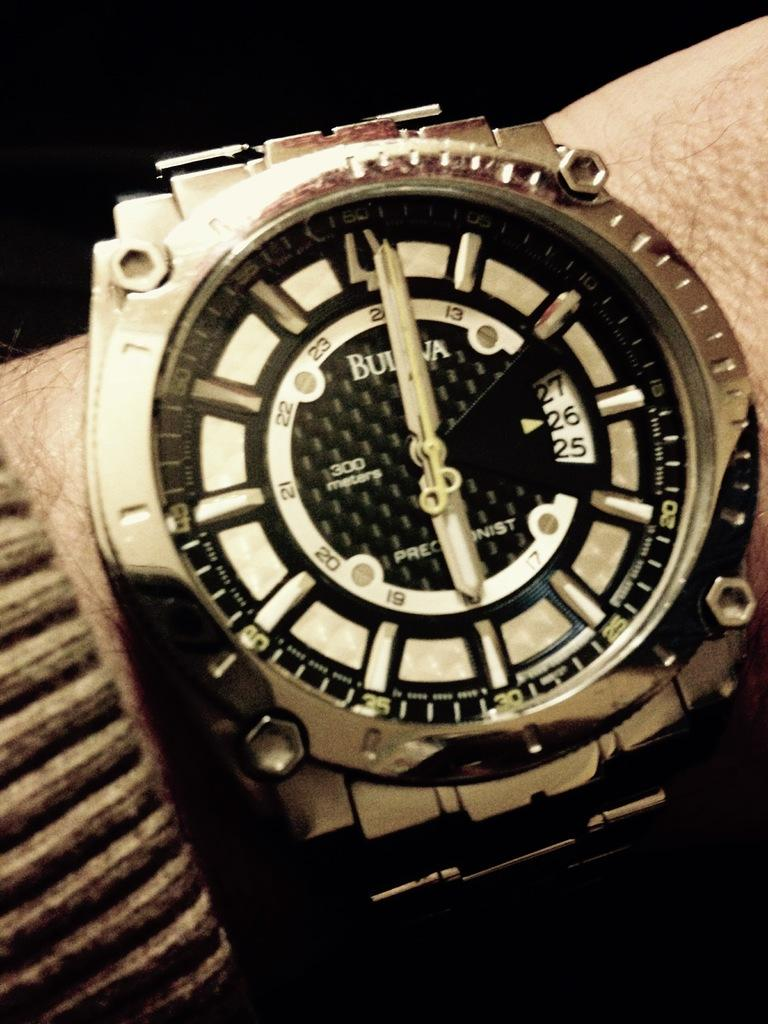<image>
Present a compact description of the photo's key features. Face of a watch which has the number 300 on it. 